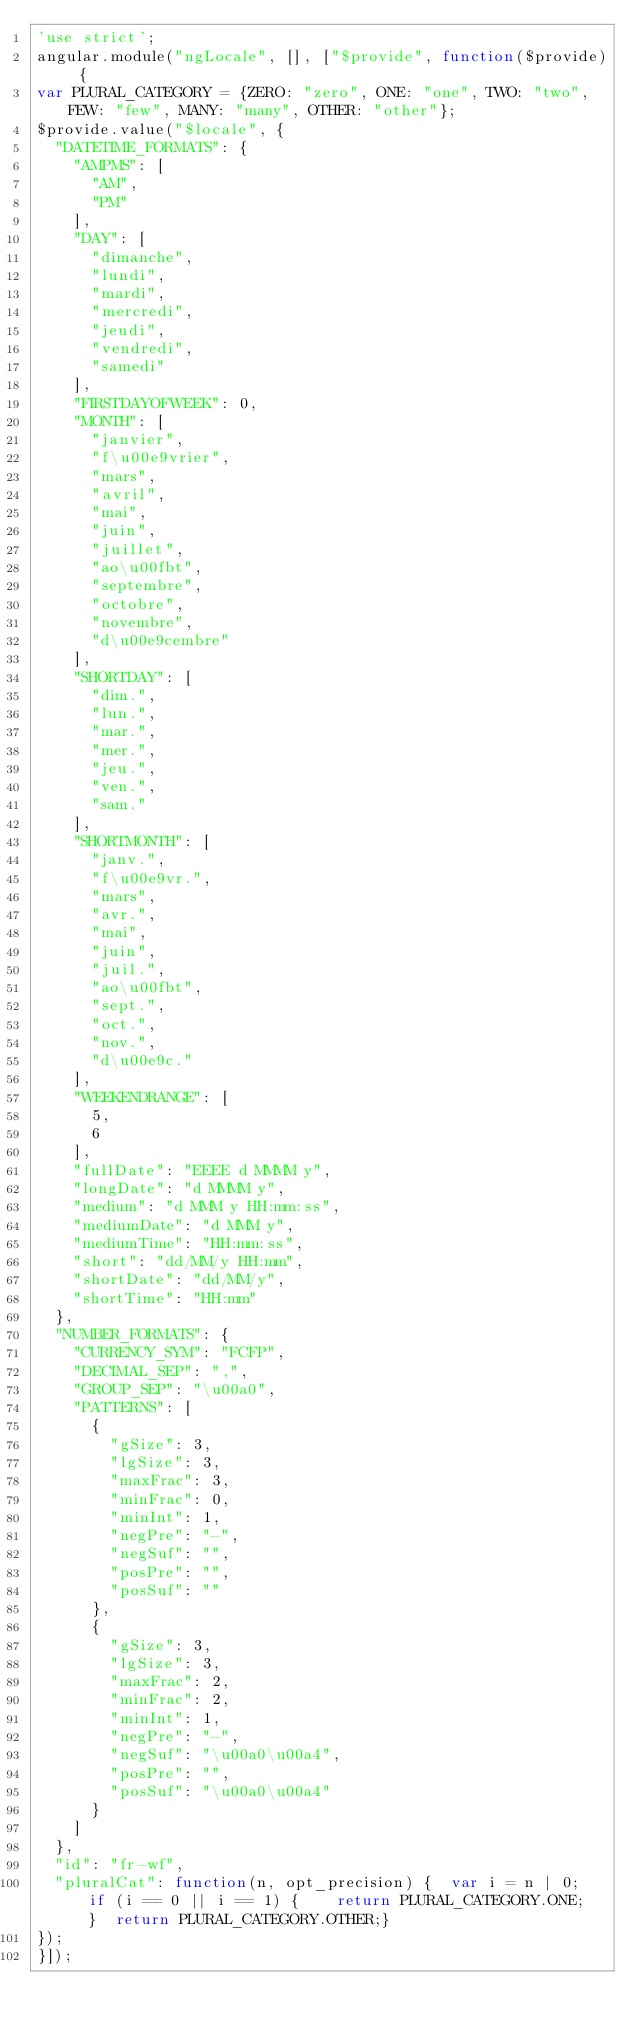Convert code to text. <code><loc_0><loc_0><loc_500><loc_500><_JavaScript_>'use strict';
angular.module("ngLocale", [], ["$provide", function($provide) {
var PLURAL_CATEGORY = {ZERO: "zero", ONE: "one", TWO: "two", FEW: "few", MANY: "many", OTHER: "other"};
$provide.value("$locale", {
  "DATETIME_FORMATS": {
    "AMPMS": [
      "AM",
      "PM"
    ],
    "DAY": [
      "dimanche",
      "lundi",
      "mardi",
      "mercredi",
      "jeudi",
      "vendredi",
      "samedi"
    ],
    "FIRSTDAYOFWEEK": 0,
    "MONTH": [
      "janvier",
      "f\u00e9vrier",
      "mars",
      "avril",
      "mai",
      "juin",
      "juillet",
      "ao\u00fbt",
      "septembre",
      "octobre",
      "novembre",
      "d\u00e9cembre"
    ],
    "SHORTDAY": [
      "dim.",
      "lun.",
      "mar.",
      "mer.",
      "jeu.",
      "ven.",
      "sam."
    ],
    "SHORTMONTH": [
      "janv.",
      "f\u00e9vr.",
      "mars",
      "avr.",
      "mai",
      "juin",
      "juil.",
      "ao\u00fbt",
      "sept.",
      "oct.",
      "nov.",
      "d\u00e9c."
    ],
    "WEEKENDRANGE": [
      5,
      6
    ],
    "fullDate": "EEEE d MMMM y",
    "longDate": "d MMMM y",
    "medium": "d MMM y HH:mm:ss",
    "mediumDate": "d MMM y",
    "mediumTime": "HH:mm:ss",
    "short": "dd/MM/y HH:mm",
    "shortDate": "dd/MM/y",
    "shortTime": "HH:mm"
  },
  "NUMBER_FORMATS": {
    "CURRENCY_SYM": "FCFP",
    "DECIMAL_SEP": ",",
    "GROUP_SEP": "\u00a0",
    "PATTERNS": [
      {
        "gSize": 3,
        "lgSize": 3,
        "maxFrac": 3,
        "minFrac": 0,
        "minInt": 1,
        "negPre": "-",
        "negSuf": "",
        "posPre": "",
        "posSuf": ""
      },
      {
        "gSize": 3,
        "lgSize": 3,
        "maxFrac": 2,
        "minFrac": 2,
        "minInt": 1,
        "negPre": "-",
        "negSuf": "\u00a0\u00a4",
        "posPre": "",
        "posSuf": "\u00a0\u00a4"
      }
    ]
  },
  "id": "fr-wf",
  "pluralCat": function(n, opt_precision) {  var i = n | 0;  if (i == 0 || i == 1) {    return PLURAL_CATEGORY.ONE;  }  return PLURAL_CATEGORY.OTHER;}
});
}]);
</code> 